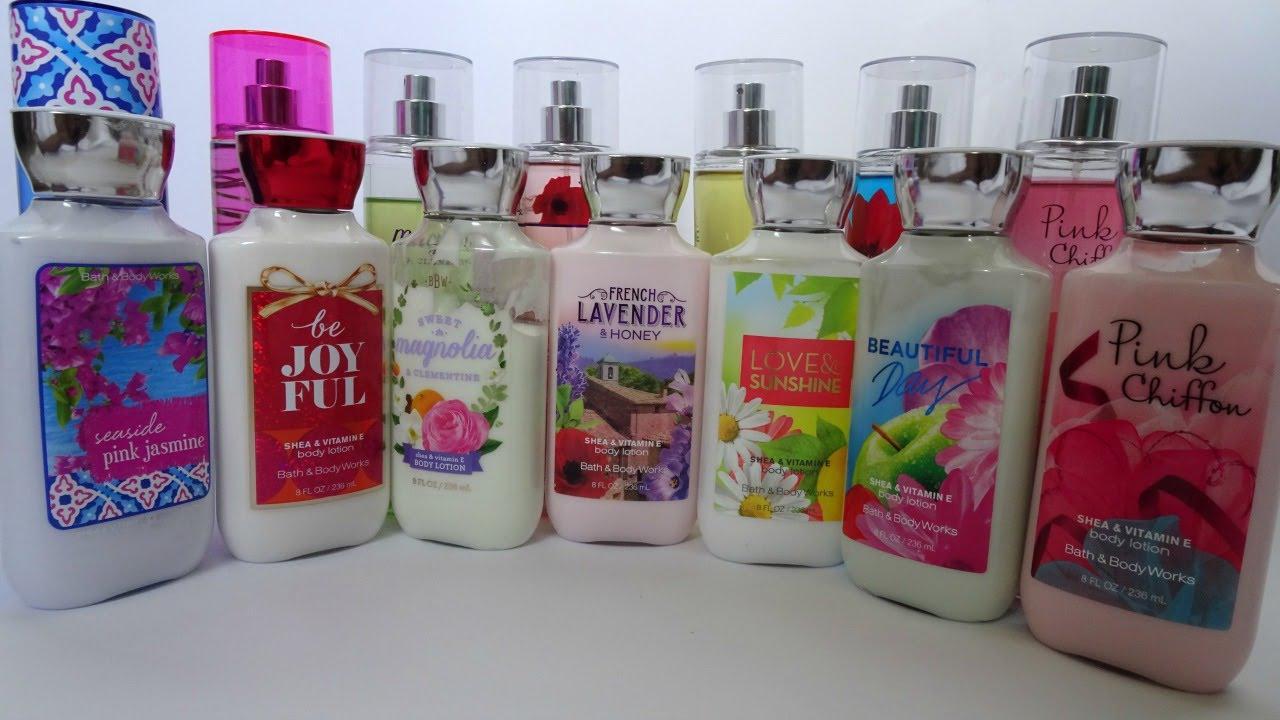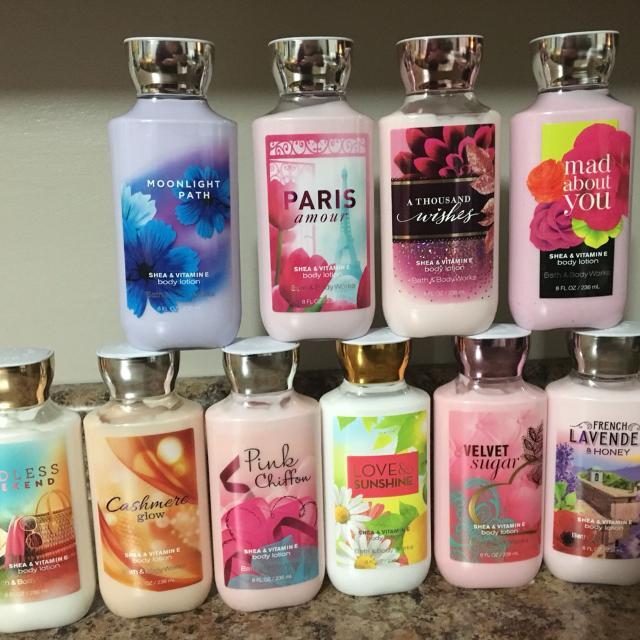The first image is the image on the left, the second image is the image on the right. For the images displayed, is the sentence "One of the images has exactly three bottles." factually correct? Answer yes or no. No. The first image is the image on the left, the second image is the image on the right. Considering the images on both sides, is "There are exactly three products in one of the images." valid? Answer yes or no. No. 